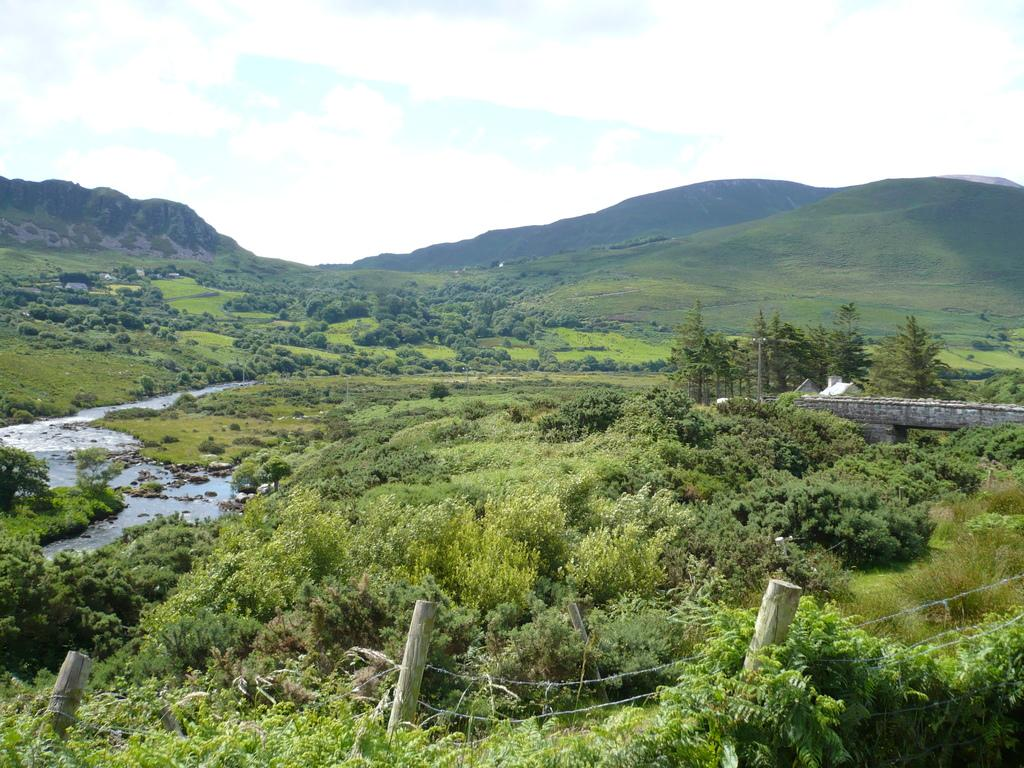What type of vegetation can be seen in the image? There is greenery in the image. Can you describe the specific type of greenery present at the bottom side of the image? Bamboos are present at the bottom side of the image. How many chickens can be seen in the image? There are no chickens present in the image. What type of trees are growing among the bamboos in the image? There are no trees mentioned in the provided facts, and the image only shows bamboos. 